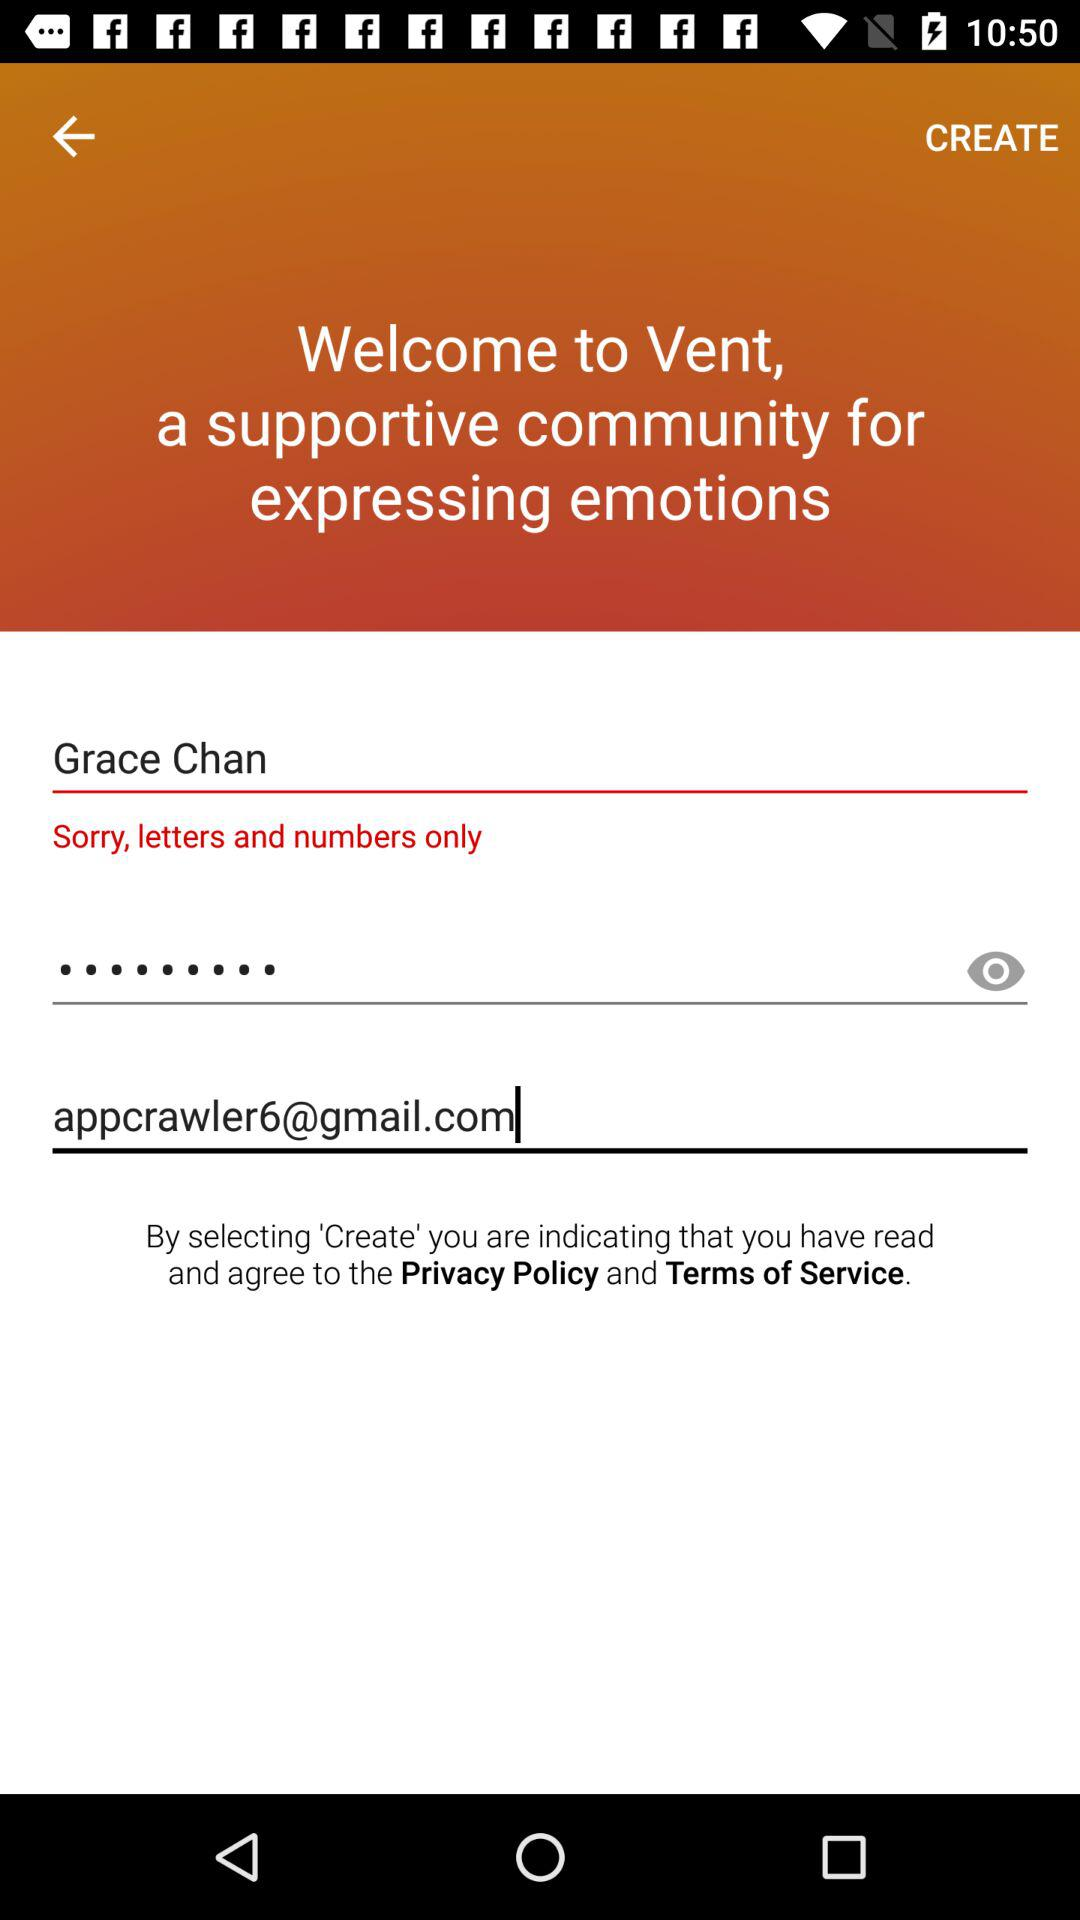What is the name of the user? The name of the user is Grace Chan. 